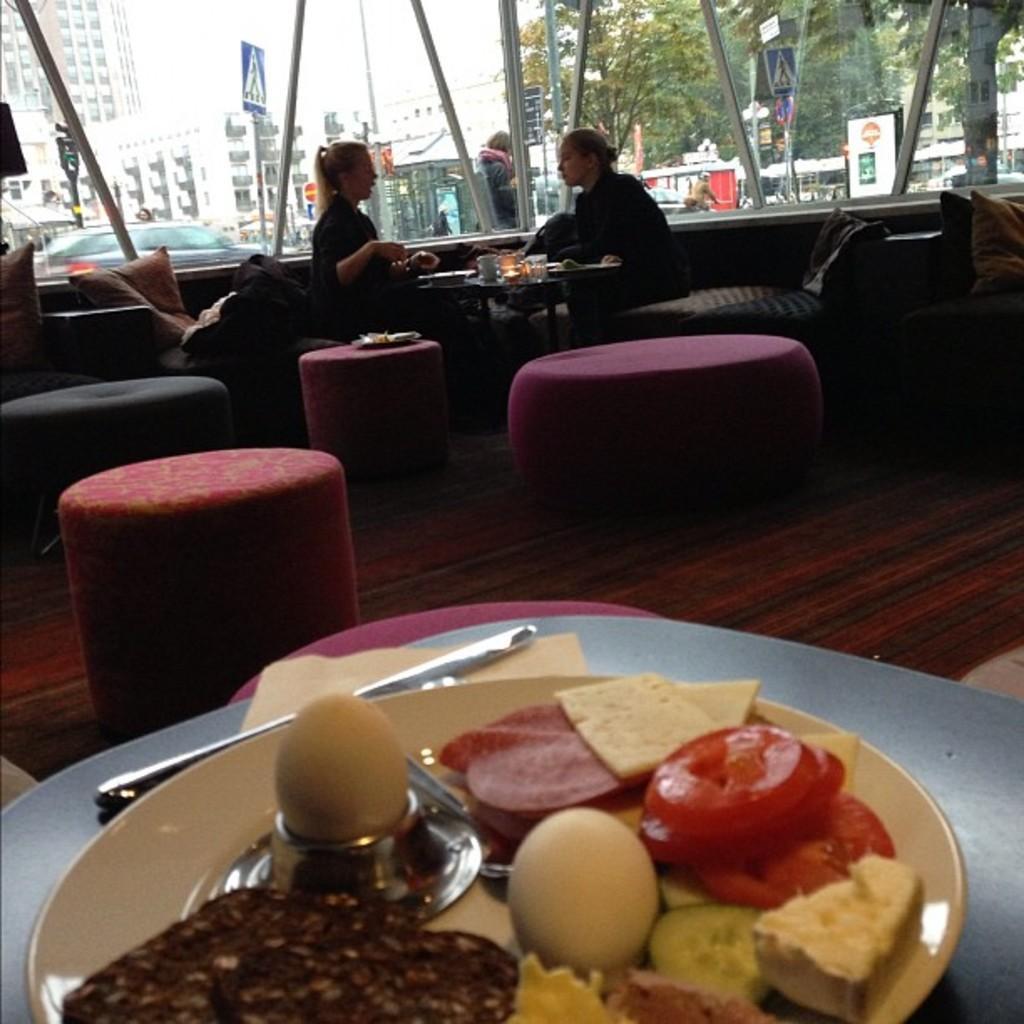How would you summarize this image in a sentence or two? This picture seems like it is inside the restaurant in which there are two women sitting in chair and having the food. At the bottom there is a plate on which there are food items. In between the room there are sofas,stools and pillows. At the background there is a glass window through which we can see the buildings and the signal board. 